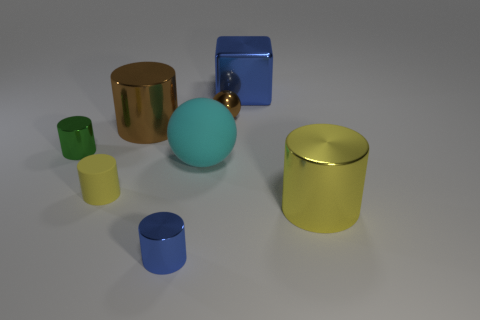Subtract all small yellow matte cylinders. How many cylinders are left? 4 Subtract all brown cylinders. How many cylinders are left? 4 Add 1 cyan balls. How many objects exist? 9 Subtract 1 blocks. How many blocks are left? 0 Subtract all yellow cylinders. How many cyan balls are left? 1 Subtract all small matte cylinders. Subtract all large blue shiny things. How many objects are left? 6 Add 4 tiny brown spheres. How many tiny brown spheres are left? 5 Add 1 small metallic cylinders. How many small metallic cylinders exist? 3 Subtract 0 blue balls. How many objects are left? 8 Subtract all blocks. How many objects are left? 7 